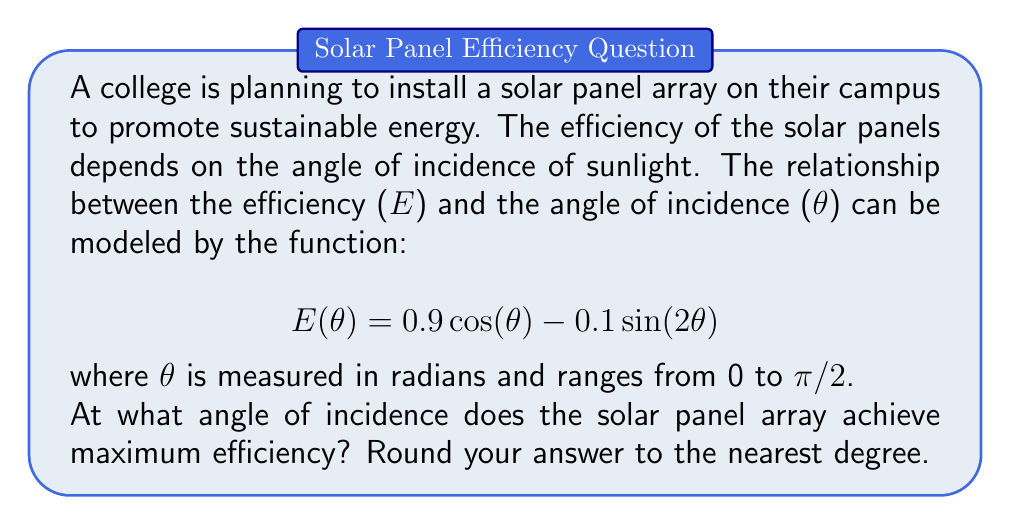What is the answer to this math problem? To find the angle of maximum efficiency, we need to find the maximum value of the function E(θ). This can be done by finding the derivative of E(θ), setting it equal to zero, and solving for θ.

1) First, let's find the derivative of E(θ):

   $$ E'(\theta) = -0.9 \sin(\theta) - 0.2 \cos(2\theta) $$

2) Now, set E'(θ) = 0 and solve for θ:

   $$ -0.9 \sin(\theta) - 0.2 \cos(2\theta) = 0 $$

3) Using the double angle formula for cosine: $\cos(2\theta) = 1 - 2\sin^2(\theta)$

   $$ -0.9 \sin(\theta) - 0.2(1 - 2\sin^2(\theta)) = 0 $$

4) Simplify:

   $$ -0.9 \sin(\theta) - 0.2 + 0.4\sin^2(\theta) = 0 $$
   $$ 0.4\sin^2(\theta) - 0.9 \sin(\theta) - 0.2 = 0 $$

5) This is a quadratic equation in terms of sin(θ). Let u = sin(θ):

   $$ 0.4u^2 - 0.9u - 0.2 = 0 $$

6) Solve using the quadratic formula:

   $$ u = \frac{0.9 \pm \sqrt{0.81 + 0.32}}{0.8} = \frac{0.9 \pm \sqrt{1.13}}{0.8} $$

7) This gives us two solutions:

   $$ u_1 = \frac{0.9 + 1.0630}{0.8} = 2.4537 $$
   $$ u_2 = \frac{0.9 - 1.0630}{0.8} = -0.2037 $$

8) Since sin(θ) must be between -1 and 1, we use u₂ = -0.2037

9) Therefore, θ = arcsin(-0.2037) ≈ -0.2054 radians

10) Convert to degrees: -0.2054 * (180/π) ≈ -11.77°

11) Since we're considering angles between 0 and π/2, we take the positive equivalent: 11.77°
Answer: The solar panel array achieves maximum efficiency at an angle of incidence of approximately 12° (rounded to the nearest degree). 